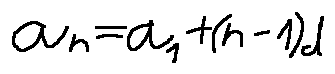<formula> <loc_0><loc_0><loc_500><loc_500>a _ { n } = a _ { 1 } + ( n - 1 ) d</formula> 